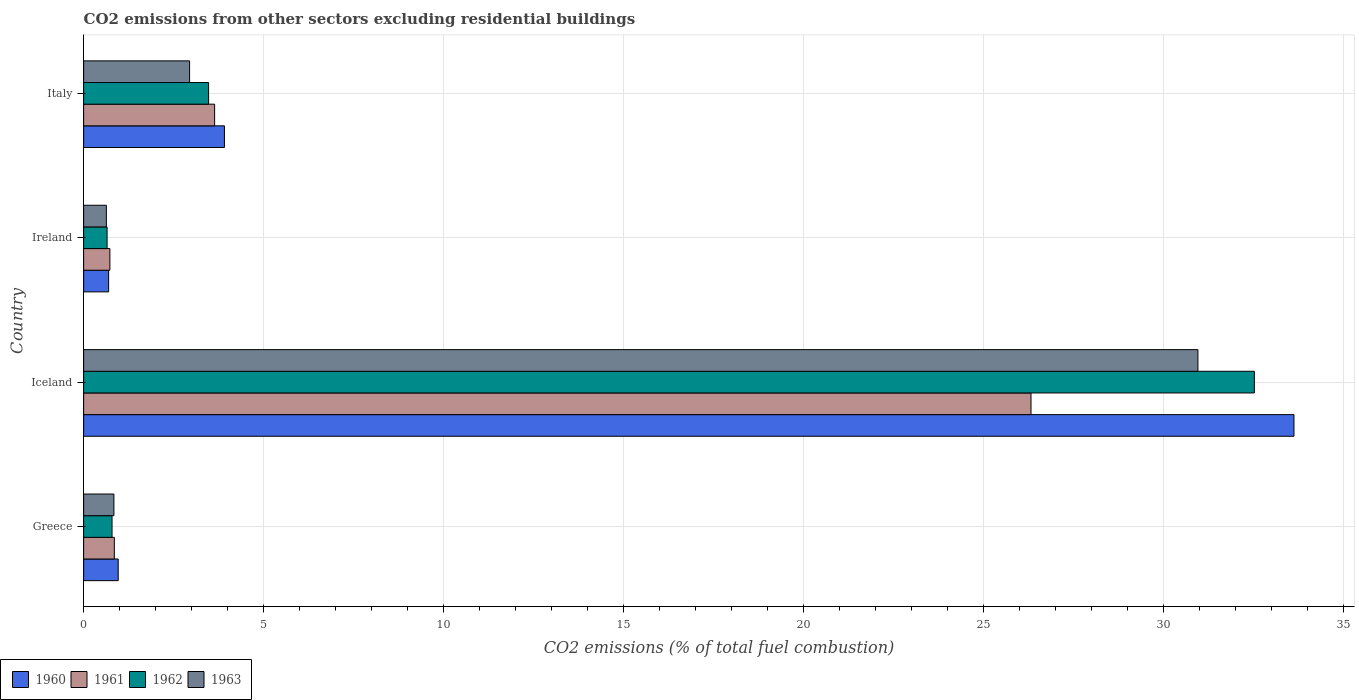How many different coloured bars are there?
Your answer should be compact. 4. Are the number of bars per tick equal to the number of legend labels?
Make the answer very short. Yes. Are the number of bars on each tick of the Y-axis equal?
Your response must be concise. Yes. How many bars are there on the 4th tick from the top?
Your answer should be compact. 4. How many bars are there on the 4th tick from the bottom?
Your answer should be compact. 4. In how many cases, is the number of bars for a given country not equal to the number of legend labels?
Provide a succinct answer. 0. What is the total CO2 emitted in 1960 in Italy?
Ensure brevity in your answer.  3.91. Across all countries, what is the maximum total CO2 emitted in 1961?
Ensure brevity in your answer.  26.32. Across all countries, what is the minimum total CO2 emitted in 1962?
Your response must be concise. 0.65. In which country was the total CO2 emitted in 1962 maximum?
Provide a short and direct response. Iceland. In which country was the total CO2 emitted in 1961 minimum?
Give a very brief answer. Ireland. What is the total total CO2 emitted in 1962 in the graph?
Provide a succinct answer. 37.43. What is the difference between the total CO2 emitted in 1963 in Greece and that in Iceland?
Your answer should be very brief. -30.11. What is the difference between the total CO2 emitted in 1961 in Greece and the total CO2 emitted in 1963 in Italy?
Offer a terse response. -2.09. What is the average total CO2 emitted in 1962 per country?
Provide a succinct answer. 9.36. What is the difference between the total CO2 emitted in 1961 and total CO2 emitted in 1960 in Ireland?
Offer a terse response. 0.03. In how many countries, is the total CO2 emitted in 1962 greater than 25 ?
Provide a succinct answer. 1. What is the ratio of the total CO2 emitted in 1963 in Iceland to that in Ireland?
Provide a short and direct response. 48.97. What is the difference between the highest and the second highest total CO2 emitted in 1963?
Offer a very short reply. 28.01. What is the difference between the highest and the lowest total CO2 emitted in 1961?
Provide a short and direct response. 25.59. Is it the case that in every country, the sum of the total CO2 emitted in 1962 and total CO2 emitted in 1961 is greater than the sum of total CO2 emitted in 1960 and total CO2 emitted in 1963?
Your answer should be compact. No. What does the 3rd bar from the top in Italy represents?
Offer a very short reply. 1961. What does the 3rd bar from the bottom in Greece represents?
Provide a short and direct response. 1962. How many bars are there?
Your answer should be very brief. 16. How many countries are there in the graph?
Offer a very short reply. 4. What is the difference between two consecutive major ticks on the X-axis?
Make the answer very short. 5. Does the graph contain any zero values?
Your answer should be very brief. No. Where does the legend appear in the graph?
Offer a very short reply. Bottom left. What is the title of the graph?
Keep it short and to the point. CO2 emissions from other sectors excluding residential buildings. Does "1986" appear as one of the legend labels in the graph?
Provide a succinct answer. No. What is the label or title of the X-axis?
Offer a very short reply. CO2 emissions (% of total fuel combustion). What is the label or title of the Y-axis?
Keep it short and to the point. Country. What is the CO2 emissions (% of total fuel combustion) in 1960 in Greece?
Your response must be concise. 0.96. What is the CO2 emissions (% of total fuel combustion) in 1961 in Greece?
Offer a very short reply. 0.85. What is the CO2 emissions (% of total fuel combustion) in 1962 in Greece?
Offer a very short reply. 0.79. What is the CO2 emissions (% of total fuel combustion) in 1963 in Greece?
Make the answer very short. 0.84. What is the CO2 emissions (% of total fuel combustion) in 1960 in Iceland?
Make the answer very short. 33.62. What is the CO2 emissions (% of total fuel combustion) in 1961 in Iceland?
Keep it short and to the point. 26.32. What is the CO2 emissions (% of total fuel combustion) in 1962 in Iceland?
Your answer should be compact. 32.52. What is the CO2 emissions (% of total fuel combustion) in 1963 in Iceland?
Provide a short and direct response. 30.95. What is the CO2 emissions (% of total fuel combustion) in 1960 in Ireland?
Provide a succinct answer. 0.69. What is the CO2 emissions (% of total fuel combustion) of 1961 in Ireland?
Make the answer very short. 0.73. What is the CO2 emissions (% of total fuel combustion) of 1962 in Ireland?
Make the answer very short. 0.65. What is the CO2 emissions (% of total fuel combustion) in 1963 in Ireland?
Provide a short and direct response. 0.63. What is the CO2 emissions (% of total fuel combustion) in 1960 in Italy?
Provide a short and direct response. 3.91. What is the CO2 emissions (% of total fuel combustion) in 1961 in Italy?
Your answer should be compact. 3.64. What is the CO2 emissions (% of total fuel combustion) in 1962 in Italy?
Provide a succinct answer. 3.47. What is the CO2 emissions (% of total fuel combustion) in 1963 in Italy?
Provide a succinct answer. 2.94. Across all countries, what is the maximum CO2 emissions (% of total fuel combustion) in 1960?
Ensure brevity in your answer.  33.62. Across all countries, what is the maximum CO2 emissions (% of total fuel combustion) of 1961?
Ensure brevity in your answer.  26.32. Across all countries, what is the maximum CO2 emissions (% of total fuel combustion) of 1962?
Make the answer very short. 32.52. Across all countries, what is the maximum CO2 emissions (% of total fuel combustion) in 1963?
Provide a succinct answer. 30.95. Across all countries, what is the minimum CO2 emissions (% of total fuel combustion) of 1960?
Provide a succinct answer. 0.69. Across all countries, what is the minimum CO2 emissions (% of total fuel combustion) of 1961?
Give a very brief answer. 0.73. Across all countries, what is the minimum CO2 emissions (% of total fuel combustion) in 1962?
Your answer should be very brief. 0.65. Across all countries, what is the minimum CO2 emissions (% of total fuel combustion) of 1963?
Offer a very short reply. 0.63. What is the total CO2 emissions (% of total fuel combustion) in 1960 in the graph?
Provide a short and direct response. 39.19. What is the total CO2 emissions (% of total fuel combustion) in 1961 in the graph?
Your answer should be compact. 31.54. What is the total CO2 emissions (% of total fuel combustion) of 1962 in the graph?
Your response must be concise. 37.43. What is the total CO2 emissions (% of total fuel combustion) in 1963 in the graph?
Ensure brevity in your answer.  35.37. What is the difference between the CO2 emissions (% of total fuel combustion) of 1960 in Greece and that in Iceland?
Give a very brief answer. -32.66. What is the difference between the CO2 emissions (% of total fuel combustion) in 1961 in Greece and that in Iceland?
Keep it short and to the point. -25.46. What is the difference between the CO2 emissions (% of total fuel combustion) in 1962 in Greece and that in Iceland?
Provide a succinct answer. -31.73. What is the difference between the CO2 emissions (% of total fuel combustion) of 1963 in Greece and that in Iceland?
Offer a very short reply. -30.11. What is the difference between the CO2 emissions (% of total fuel combustion) in 1960 in Greece and that in Ireland?
Provide a succinct answer. 0.27. What is the difference between the CO2 emissions (% of total fuel combustion) of 1961 in Greece and that in Ireland?
Your answer should be very brief. 0.12. What is the difference between the CO2 emissions (% of total fuel combustion) of 1962 in Greece and that in Ireland?
Your response must be concise. 0.14. What is the difference between the CO2 emissions (% of total fuel combustion) of 1963 in Greece and that in Ireland?
Give a very brief answer. 0.21. What is the difference between the CO2 emissions (% of total fuel combustion) in 1960 in Greece and that in Italy?
Make the answer very short. -2.95. What is the difference between the CO2 emissions (% of total fuel combustion) of 1961 in Greece and that in Italy?
Give a very brief answer. -2.79. What is the difference between the CO2 emissions (% of total fuel combustion) in 1962 in Greece and that in Italy?
Your response must be concise. -2.68. What is the difference between the CO2 emissions (% of total fuel combustion) of 1963 in Greece and that in Italy?
Your answer should be compact. -2.1. What is the difference between the CO2 emissions (% of total fuel combustion) in 1960 in Iceland and that in Ireland?
Your answer should be very brief. 32.93. What is the difference between the CO2 emissions (% of total fuel combustion) of 1961 in Iceland and that in Ireland?
Provide a short and direct response. 25.59. What is the difference between the CO2 emissions (% of total fuel combustion) of 1962 in Iceland and that in Ireland?
Your response must be concise. 31.87. What is the difference between the CO2 emissions (% of total fuel combustion) in 1963 in Iceland and that in Ireland?
Ensure brevity in your answer.  30.32. What is the difference between the CO2 emissions (% of total fuel combustion) of 1960 in Iceland and that in Italy?
Keep it short and to the point. 29.71. What is the difference between the CO2 emissions (% of total fuel combustion) in 1961 in Iceland and that in Italy?
Give a very brief answer. 22.68. What is the difference between the CO2 emissions (% of total fuel combustion) in 1962 in Iceland and that in Italy?
Give a very brief answer. 29.05. What is the difference between the CO2 emissions (% of total fuel combustion) of 1963 in Iceland and that in Italy?
Give a very brief answer. 28.01. What is the difference between the CO2 emissions (% of total fuel combustion) in 1960 in Ireland and that in Italy?
Offer a terse response. -3.22. What is the difference between the CO2 emissions (% of total fuel combustion) of 1961 in Ireland and that in Italy?
Your response must be concise. -2.91. What is the difference between the CO2 emissions (% of total fuel combustion) in 1962 in Ireland and that in Italy?
Provide a succinct answer. -2.82. What is the difference between the CO2 emissions (% of total fuel combustion) in 1963 in Ireland and that in Italy?
Ensure brevity in your answer.  -2.31. What is the difference between the CO2 emissions (% of total fuel combustion) of 1960 in Greece and the CO2 emissions (% of total fuel combustion) of 1961 in Iceland?
Offer a very short reply. -25.36. What is the difference between the CO2 emissions (% of total fuel combustion) in 1960 in Greece and the CO2 emissions (% of total fuel combustion) in 1962 in Iceland?
Give a very brief answer. -31.56. What is the difference between the CO2 emissions (% of total fuel combustion) of 1960 in Greece and the CO2 emissions (% of total fuel combustion) of 1963 in Iceland?
Your answer should be compact. -29.99. What is the difference between the CO2 emissions (% of total fuel combustion) of 1961 in Greece and the CO2 emissions (% of total fuel combustion) of 1962 in Iceland?
Offer a terse response. -31.67. What is the difference between the CO2 emissions (% of total fuel combustion) of 1961 in Greece and the CO2 emissions (% of total fuel combustion) of 1963 in Iceland?
Offer a terse response. -30.1. What is the difference between the CO2 emissions (% of total fuel combustion) of 1962 in Greece and the CO2 emissions (% of total fuel combustion) of 1963 in Iceland?
Give a very brief answer. -30.16. What is the difference between the CO2 emissions (% of total fuel combustion) in 1960 in Greece and the CO2 emissions (% of total fuel combustion) in 1961 in Ireland?
Offer a very short reply. 0.23. What is the difference between the CO2 emissions (% of total fuel combustion) in 1960 in Greece and the CO2 emissions (% of total fuel combustion) in 1962 in Ireland?
Make the answer very short. 0.31. What is the difference between the CO2 emissions (% of total fuel combustion) in 1960 in Greece and the CO2 emissions (% of total fuel combustion) in 1963 in Ireland?
Ensure brevity in your answer.  0.33. What is the difference between the CO2 emissions (% of total fuel combustion) in 1961 in Greece and the CO2 emissions (% of total fuel combustion) in 1962 in Ireland?
Provide a succinct answer. 0.2. What is the difference between the CO2 emissions (% of total fuel combustion) in 1961 in Greece and the CO2 emissions (% of total fuel combustion) in 1963 in Ireland?
Provide a short and direct response. 0.22. What is the difference between the CO2 emissions (% of total fuel combustion) in 1962 in Greece and the CO2 emissions (% of total fuel combustion) in 1963 in Ireland?
Ensure brevity in your answer.  0.16. What is the difference between the CO2 emissions (% of total fuel combustion) in 1960 in Greece and the CO2 emissions (% of total fuel combustion) in 1961 in Italy?
Your answer should be compact. -2.68. What is the difference between the CO2 emissions (% of total fuel combustion) in 1960 in Greece and the CO2 emissions (% of total fuel combustion) in 1962 in Italy?
Your answer should be compact. -2.51. What is the difference between the CO2 emissions (% of total fuel combustion) in 1960 in Greece and the CO2 emissions (% of total fuel combustion) in 1963 in Italy?
Your answer should be very brief. -1.98. What is the difference between the CO2 emissions (% of total fuel combustion) in 1961 in Greece and the CO2 emissions (% of total fuel combustion) in 1962 in Italy?
Keep it short and to the point. -2.62. What is the difference between the CO2 emissions (% of total fuel combustion) of 1961 in Greece and the CO2 emissions (% of total fuel combustion) of 1963 in Italy?
Offer a terse response. -2.09. What is the difference between the CO2 emissions (% of total fuel combustion) of 1962 in Greece and the CO2 emissions (% of total fuel combustion) of 1963 in Italy?
Provide a succinct answer. -2.15. What is the difference between the CO2 emissions (% of total fuel combustion) of 1960 in Iceland and the CO2 emissions (% of total fuel combustion) of 1961 in Ireland?
Provide a succinct answer. 32.89. What is the difference between the CO2 emissions (% of total fuel combustion) in 1960 in Iceland and the CO2 emissions (% of total fuel combustion) in 1962 in Ireland?
Your answer should be compact. 32.97. What is the difference between the CO2 emissions (% of total fuel combustion) of 1960 in Iceland and the CO2 emissions (% of total fuel combustion) of 1963 in Ireland?
Your answer should be very brief. 32.99. What is the difference between the CO2 emissions (% of total fuel combustion) in 1961 in Iceland and the CO2 emissions (% of total fuel combustion) in 1962 in Ireland?
Provide a succinct answer. 25.66. What is the difference between the CO2 emissions (% of total fuel combustion) of 1961 in Iceland and the CO2 emissions (% of total fuel combustion) of 1963 in Ireland?
Provide a succinct answer. 25.68. What is the difference between the CO2 emissions (% of total fuel combustion) in 1962 in Iceland and the CO2 emissions (% of total fuel combustion) in 1963 in Ireland?
Ensure brevity in your answer.  31.89. What is the difference between the CO2 emissions (% of total fuel combustion) in 1960 in Iceland and the CO2 emissions (% of total fuel combustion) in 1961 in Italy?
Provide a succinct answer. 29.98. What is the difference between the CO2 emissions (% of total fuel combustion) of 1960 in Iceland and the CO2 emissions (% of total fuel combustion) of 1962 in Italy?
Your answer should be very brief. 30.15. What is the difference between the CO2 emissions (% of total fuel combustion) in 1960 in Iceland and the CO2 emissions (% of total fuel combustion) in 1963 in Italy?
Provide a short and direct response. 30.68. What is the difference between the CO2 emissions (% of total fuel combustion) of 1961 in Iceland and the CO2 emissions (% of total fuel combustion) of 1962 in Italy?
Keep it short and to the point. 22.84. What is the difference between the CO2 emissions (% of total fuel combustion) in 1961 in Iceland and the CO2 emissions (% of total fuel combustion) in 1963 in Italy?
Offer a terse response. 23.37. What is the difference between the CO2 emissions (% of total fuel combustion) of 1962 in Iceland and the CO2 emissions (% of total fuel combustion) of 1963 in Italy?
Offer a very short reply. 29.58. What is the difference between the CO2 emissions (% of total fuel combustion) of 1960 in Ireland and the CO2 emissions (% of total fuel combustion) of 1961 in Italy?
Offer a terse response. -2.94. What is the difference between the CO2 emissions (% of total fuel combustion) in 1960 in Ireland and the CO2 emissions (% of total fuel combustion) in 1962 in Italy?
Give a very brief answer. -2.78. What is the difference between the CO2 emissions (% of total fuel combustion) of 1960 in Ireland and the CO2 emissions (% of total fuel combustion) of 1963 in Italy?
Your response must be concise. -2.25. What is the difference between the CO2 emissions (% of total fuel combustion) in 1961 in Ireland and the CO2 emissions (% of total fuel combustion) in 1962 in Italy?
Offer a very short reply. -2.74. What is the difference between the CO2 emissions (% of total fuel combustion) of 1961 in Ireland and the CO2 emissions (% of total fuel combustion) of 1963 in Italy?
Make the answer very short. -2.21. What is the difference between the CO2 emissions (% of total fuel combustion) of 1962 in Ireland and the CO2 emissions (% of total fuel combustion) of 1963 in Italy?
Your answer should be compact. -2.29. What is the average CO2 emissions (% of total fuel combustion) in 1960 per country?
Provide a succinct answer. 9.8. What is the average CO2 emissions (% of total fuel combustion) in 1961 per country?
Offer a very short reply. 7.88. What is the average CO2 emissions (% of total fuel combustion) in 1962 per country?
Your answer should be compact. 9.36. What is the average CO2 emissions (% of total fuel combustion) of 1963 per country?
Your response must be concise. 8.84. What is the difference between the CO2 emissions (% of total fuel combustion) in 1960 and CO2 emissions (% of total fuel combustion) in 1961 in Greece?
Provide a short and direct response. 0.11. What is the difference between the CO2 emissions (% of total fuel combustion) of 1960 and CO2 emissions (% of total fuel combustion) of 1962 in Greece?
Your answer should be compact. 0.17. What is the difference between the CO2 emissions (% of total fuel combustion) of 1960 and CO2 emissions (% of total fuel combustion) of 1963 in Greece?
Make the answer very short. 0.12. What is the difference between the CO2 emissions (% of total fuel combustion) in 1961 and CO2 emissions (% of total fuel combustion) in 1962 in Greece?
Provide a short and direct response. 0.06. What is the difference between the CO2 emissions (% of total fuel combustion) of 1961 and CO2 emissions (% of total fuel combustion) of 1963 in Greece?
Keep it short and to the point. 0.01. What is the difference between the CO2 emissions (% of total fuel combustion) in 1962 and CO2 emissions (% of total fuel combustion) in 1963 in Greece?
Offer a very short reply. -0.05. What is the difference between the CO2 emissions (% of total fuel combustion) in 1960 and CO2 emissions (% of total fuel combustion) in 1961 in Iceland?
Ensure brevity in your answer.  7.3. What is the difference between the CO2 emissions (% of total fuel combustion) of 1960 and CO2 emissions (% of total fuel combustion) of 1962 in Iceland?
Provide a succinct answer. 1.1. What is the difference between the CO2 emissions (% of total fuel combustion) in 1960 and CO2 emissions (% of total fuel combustion) in 1963 in Iceland?
Your response must be concise. 2.67. What is the difference between the CO2 emissions (% of total fuel combustion) of 1961 and CO2 emissions (% of total fuel combustion) of 1962 in Iceland?
Keep it short and to the point. -6.2. What is the difference between the CO2 emissions (% of total fuel combustion) of 1961 and CO2 emissions (% of total fuel combustion) of 1963 in Iceland?
Give a very brief answer. -4.64. What is the difference between the CO2 emissions (% of total fuel combustion) of 1962 and CO2 emissions (% of total fuel combustion) of 1963 in Iceland?
Give a very brief answer. 1.57. What is the difference between the CO2 emissions (% of total fuel combustion) of 1960 and CO2 emissions (% of total fuel combustion) of 1961 in Ireland?
Make the answer very short. -0.03. What is the difference between the CO2 emissions (% of total fuel combustion) of 1960 and CO2 emissions (% of total fuel combustion) of 1962 in Ireland?
Provide a succinct answer. 0.04. What is the difference between the CO2 emissions (% of total fuel combustion) in 1960 and CO2 emissions (% of total fuel combustion) in 1963 in Ireland?
Your answer should be compact. 0.06. What is the difference between the CO2 emissions (% of total fuel combustion) in 1961 and CO2 emissions (% of total fuel combustion) in 1962 in Ireland?
Your response must be concise. 0.08. What is the difference between the CO2 emissions (% of total fuel combustion) of 1961 and CO2 emissions (% of total fuel combustion) of 1963 in Ireland?
Offer a terse response. 0.1. What is the difference between the CO2 emissions (% of total fuel combustion) in 1962 and CO2 emissions (% of total fuel combustion) in 1963 in Ireland?
Make the answer very short. 0.02. What is the difference between the CO2 emissions (% of total fuel combustion) of 1960 and CO2 emissions (% of total fuel combustion) of 1961 in Italy?
Provide a short and direct response. 0.27. What is the difference between the CO2 emissions (% of total fuel combustion) in 1960 and CO2 emissions (% of total fuel combustion) in 1962 in Italy?
Provide a short and direct response. 0.44. What is the difference between the CO2 emissions (% of total fuel combustion) of 1961 and CO2 emissions (% of total fuel combustion) of 1962 in Italy?
Offer a very short reply. 0.17. What is the difference between the CO2 emissions (% of total fuel combustion) in 1961 and CO2 emissions (% of total fuel combustion) in 1963 in Italy?
Provide a succinct answer. 0.7. What is the difference between the CO2 emissions (% of total fuel combustion) of 1962 and CO2 emissions (% of total fuel combustion) of 1963 in Italy?
Provide a short and direct response. 0.53. What is the ratio of the CO2 emissions (% of total fuel combustion) of 1960 in Greece to that in Iceland?
Your response must be concise. 0.03. What is the ratio of the CO2 emissions (% of total fuel combustion) of 1961 in Greece to that in Iceland?
Your answer should be compact. 0.03. What is the ratio of the CO2 emissions (% of total fuel combustion) in 1962 in Greece to that in Iceland?
Offer a terse response. 0.02. What is the ratio of the CO2 emissions (% of total fuel combustion) of 1963 in Greece to that in Iceland?
Keep it short and to the point. 0.03. What is the ratio of the CO2 emissions (% of total fuel combustion) of 1960 in Greece to that in Ireland?
Make the answer very short. 1.38. What is the ratio of the CO2 emissions (% of total fuel combustion) of 1961 in Greece to that in Ireland?
Offer a terse response. 1.17. What is the ratio of the CO2 emissions (% of total fuel combustion) of 1962 in Greece to that in Ireland?
Provide a succinct answer. 1.21. What is the ratio of the CO2 emissions (% of total fuel combustion) of 1963 in Greece to that in Ireland?
Provide a short and direct response. 1.33. What is the ratio of the CO2 emissions (% of total fuel combustion) of 1960 in Greece to that in Italy?
Keep it short and to the point. 0.25. What is the ratio of the CO2 emissions (% of total fuel combustion) of 1961 in Greece to that in Italy?
Your answer should be very brief. 0.23. What is the ratio of the CO2 emissions (% of total fuel combustion) in 1962 in Greece to that in Italy?
Your response must be concise. 0.23. What is the ratio of the CO2 emissions (% of total fuel combustion) of 1963 in Greece to that in Italy?
Ensure brevity in your answer.  0.29. What is the ratio of the CO2 emissions (% of total fuel combustion) of 1960 in Iceland to that in Ireland?
Give a very brief answer. 48.41. What is the ratio of the CO2 emissions (% of total fuel combustion) of 1961 in Iceland to that in Ireland?
Keep it short and to the point. 36.11. What is the ratio of the CO2 emissions (% of total fuel combustion) in 1962 in Iceland to that in Ireland?
Provide a succinct answer. 49.94. What is the ratio of the CO2 emissions (% of total fuel combustion) of 1963 in Iceland to that in Ireland?
Your answer should be very brief. 48.97. What is the ratio of the CO2 emissions (% of total fuel combustion) of 1960 in Iceland to that in Italy?
Give a very brief answer. 8.6. What is the ratio of the CO2 emissions (% of total fuel combustion) in 1961 in Iceland to that in Italy?
Provide a short and direct response. 7.23. What is the ratio of the CO2 emissions (% of total fuel combustion) in 1962 in Iceland to that in Italy?
Your response must be concise. 9.37. What is the ratio of the CO2 emissions (% of total fuel combustion) of 1963 in Iceland to that in Italy?
Ensure brevity in your answer.  10.52. What is the ratio of the CO2 emissions (% of total fuel combustion) in 1960 in Ireland to that in Italy?
Provide a short and direct response. 0.18. What is the ratio of the CO2 emissions (% of total fuel combustion) in 1961 in Ireland to that in Italy?
Provide a short and direct response. 0.2. What is the ratio of the CO2 emissions (% of total fuel combustion) in 1962 in Ireland to that in Italy?
Provide a succinct answer. 0.19. What is the ratio of the CO2 emissions (% of total fuel combustion) of 1963 in Ireland to that in Italy?
Offer a very short reply. 0.21. What is the difference between the highest and the second highest CO2 emissions (% of total fuel combustion) in 1960?
Offer a terse response. 29.71. What is the difference between the highest and the second highest CO2 emissions (% of total fuel combustion) in 1961?
Keep it short and to the point. 22.68. What is the difference between the highest and the second highest CO2 emissions (% of total fuel combustion) in 1962?
Provide a short and direct response. 29.05. What is the difference between the highest and the second highest CO2 emissions (% of total fuel combustion) in 1963?
Your answer should be very brief. 28.01. What is the difference between the highest and the lowest CO2 emissions (% of total fuel combustion) of 1960?
Ensure brevity in your answer.  32.93. What is the difference between the highest and the lowest CO2 emissions (% of total fuel combustion) in 1961?
Your answer should be compact. 25.59. What is the difference between the highest and the lowest CO2 emissions (% of total fuel combustion) of 1962?
Keep it short and to the point. 31.87. What is the difference between the highest and the lowest CO2 emissions (% of total fuel combustion) in 1963?
Keep it short and to the point. 30.32. 